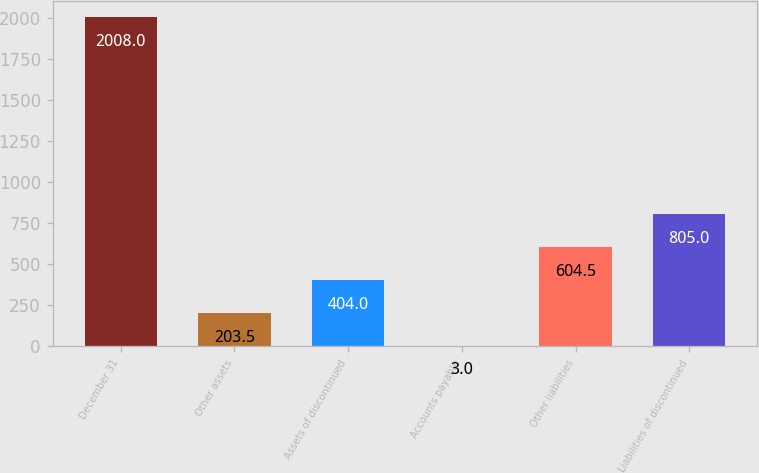<chart> <loc_0><loc_0><loc_500><loc_500><bar_chart><fcel>December 31<fcel>Other assets<fcel>Assets of discontinued<fcel>Accounts payable<fcel>Other liabilities<fcel>Liabilities of discontinued<nl><fcel>2008<fcel>203.5<fcel>404<fcel>3<fcel>604.5<fcel>805<nl></chart> 